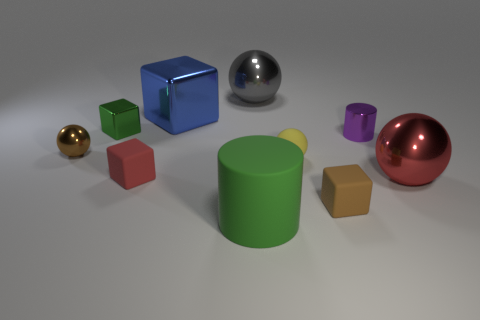Are there more red objects than big purple shiny balls?
Provide a short and direct response. Yes. Do the cylinder on the left side of the brown cube and the big ball that is on the right side of the small brown matte block have the same color?
Give a very brief answer. No. Do the cylinder that is behind the big red thing and the thing that is right of the tiny purple shiny cylinder have the same material?
Your answer should be compact. Yes. How many blue objects are the same size as the yellow rubber thing?
Your answer should be very brief. 0. Is the number of big blue cubes less than the number of tiny yellow shiny spheres?
Offer a terse response. No. What shape is the small metallic object on the right side of the tiny block behind the purple metallic object?
Offer a very short reply. Cylinder. There is a brown rubber object that is the same size as the purple thing; what shape is it?
Keep it short and to the point. Cube. Are there any other tiny green things of the same shape as the green metal object?
Your answer should be compact. No. What is the tiny yellow thing made of?
Your answer should be very brief. Rubber. Are there any small blocks behind the tiny brown matte block?
Your response must be concise. Yes. 